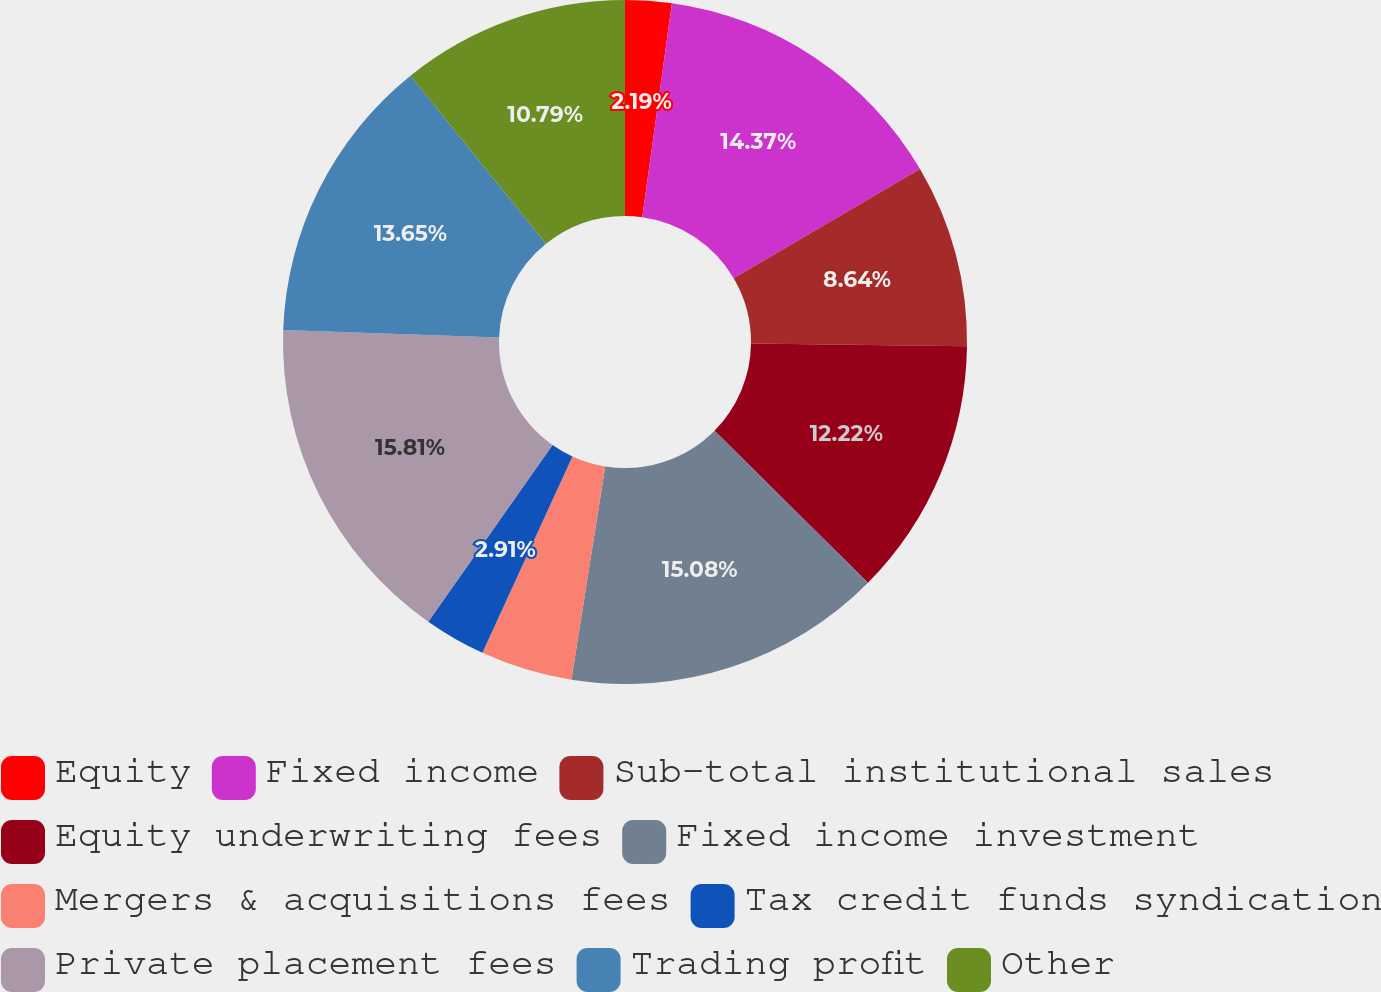Convert chart to OTSL. <chart><loc_0><loc_0><loc_500><loc_500><pie_chart><fcel>Equity<fcel>Fixed income<fcel>Sub-total institutional sales<fcel>Equity underwriting fees<fcel>Fixed income investment<fcel>Mergers & acquisitions fees<fcel>Tax credit funds syndication<fcel>Private placement fees<fcel>Trading profit<fcel>Other<nl><fcel>2.19%<fcel>14.37%<fcel>8.64%<fcel>12.22%<fcel>15.08%<fcel>4.34%<fcel>2.91%<fcel>15.8%<fcel>13.65%<fcel>10.79%<nl></chart> 